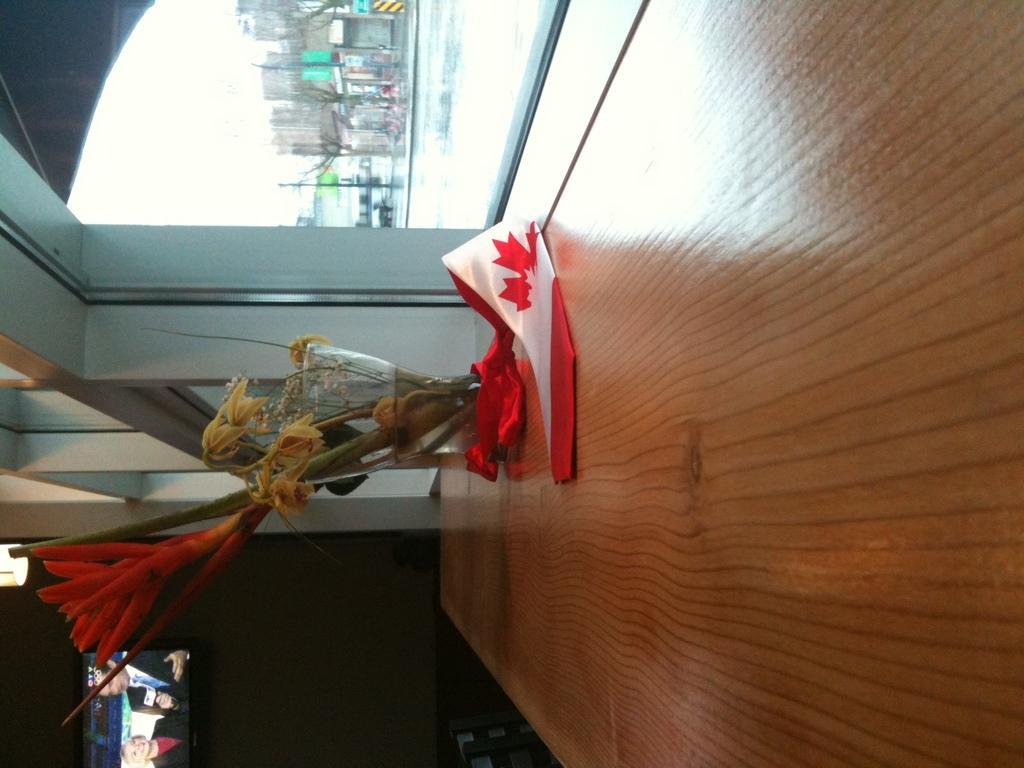How would you summarize this image in a sentence or two? In the foreground I can see a flower vase on the table, window, water, buildings, trees and the sky. This image is taken may be during a day. 